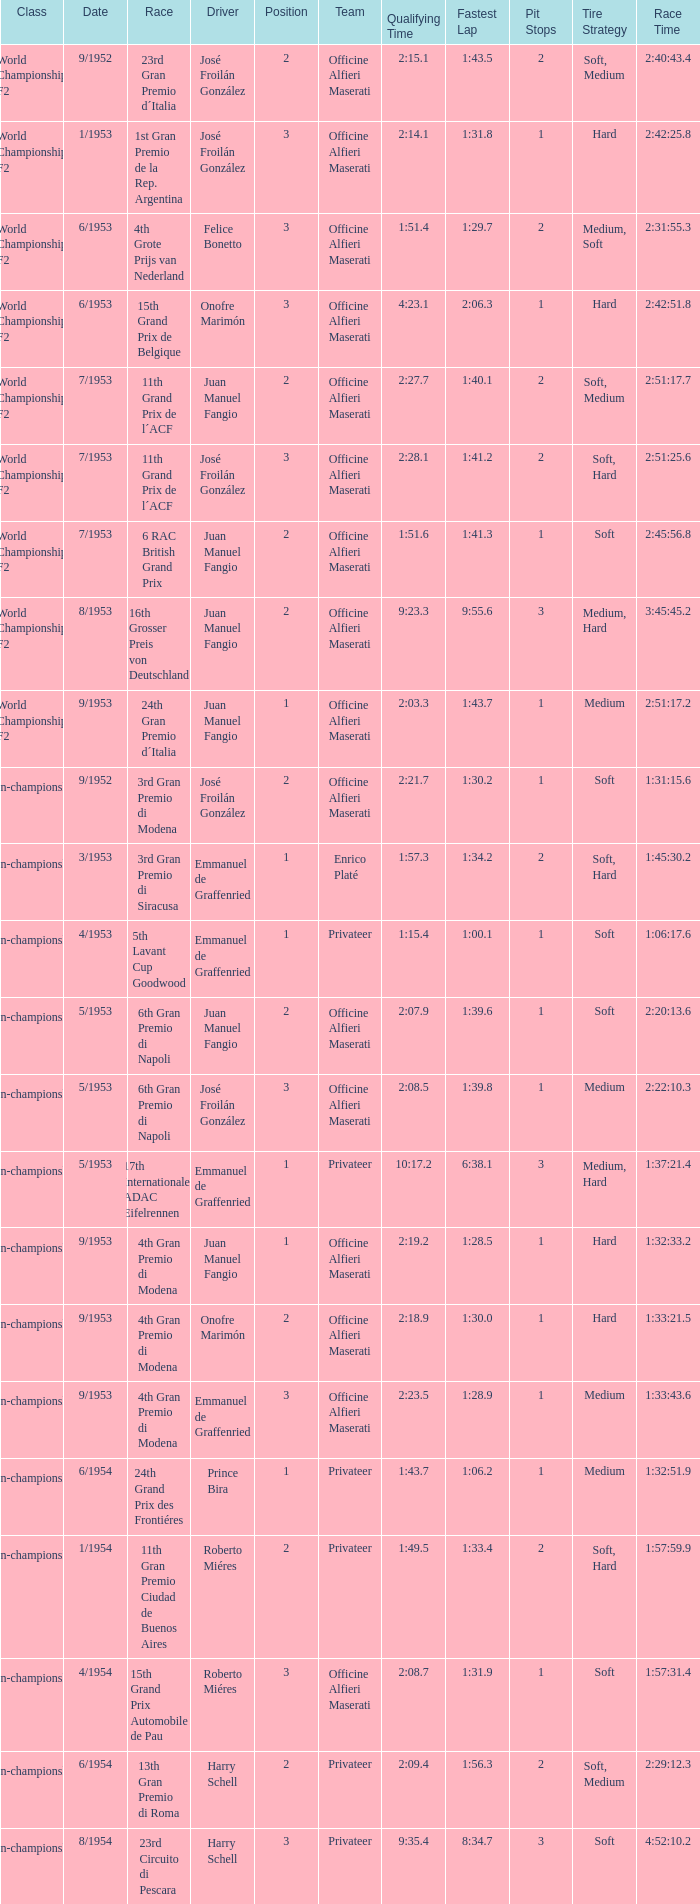What class has the date of 8/1954? Non-championship F1. 